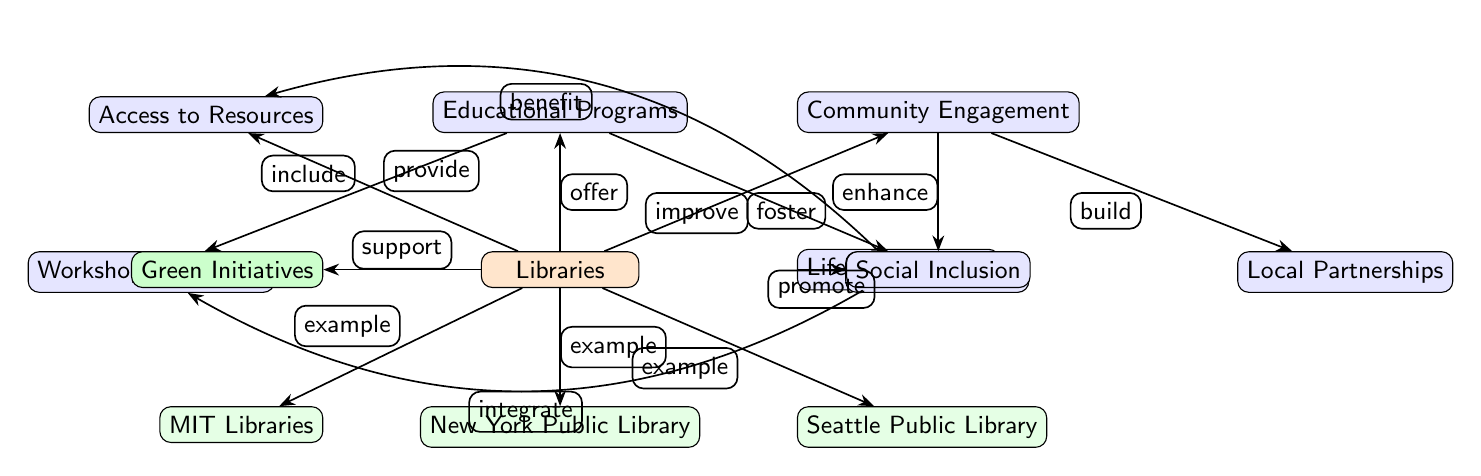What is the main node in the diagram? The main node is labeled "Libraries", which serves as the central theme around which other elements are connected.
Answer: Libraries How many sub-nodes are connected to the main node? The main node "Libraries" has four direct sub-nodes: "Access to Resources", "Educational Programs", "Community Engagement", and "Lifelong Learning", hence there are four sub-nodes.
Answer: 4 What does "Educational Programs" directly include? The sub-node "Educational Programs" directly includes two elements: "Workshops & Classes" and "Digital Literacy".
Answer: Workshops & Classes, Digital Literacy What is the relationship between "Lifelong Learning" and "Access to Resources"? The role of "Lifelong Learning" enhances "Access to Resources", as indicated by the connected arrow labeled "benefit".
Answer: benefit Which sub-node supports green initiatives? The diagram indicates that "Libraries" supports "Green Initiatives", denoted by the arrow labeled "support" directed towards the "Green Initiatives" sub-node.
Answer: Green Initiatives Which example library is located to the left of the main node? The example library to the left of the main node "Libraries" is "MIT Libraries", as shown in the diagram positioning.
Answer: MIT Libraries What are the benefits of "Community Engagement" according to the diagram? "Community Engagement" fosters local partnerships and enhances social inclusion, indicated by the arrows connecting these sub-nodes.
Answer: Local Partnerships, Social Inclusion How many instances of "example" libraries are shown in the diagram? There are three example libraries in the diagram: "MIT Libraries", "New York Public Library", and "Seattle Public Library", giving a total of three examples.
Answer: 3 What role does "Lifelong Learning" play in relation to "Social Inclusion"? "Lifelong Learning" promotes "Social Inclusion", as shown by the connection indicating its supportive role towards this sub-node.
Answer: promote 